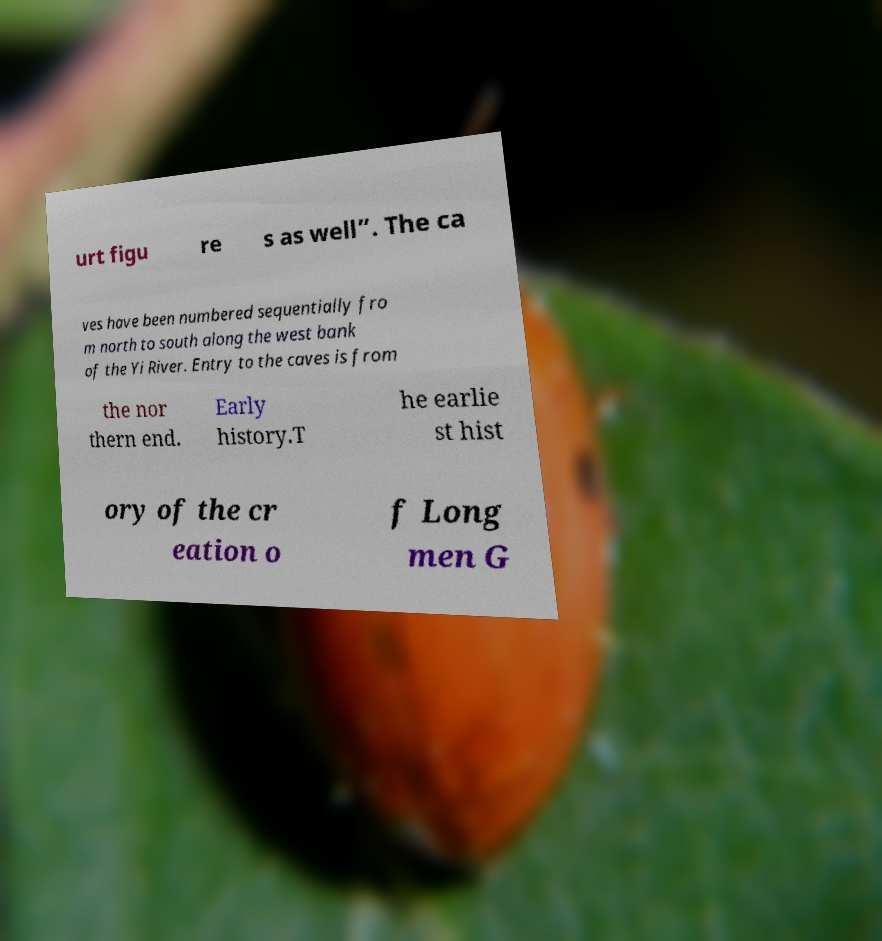There's text embedded in this image that I need extracted. Can you transcribe it verbatim? urt figu re s as well”. The ca ves have been numbered sequentially fro m north to south along the west bank of the Yi River. Entry to the caves is from the nor thern end. Early history.T he earlie st hist ory of the cr eation o f Long men G 